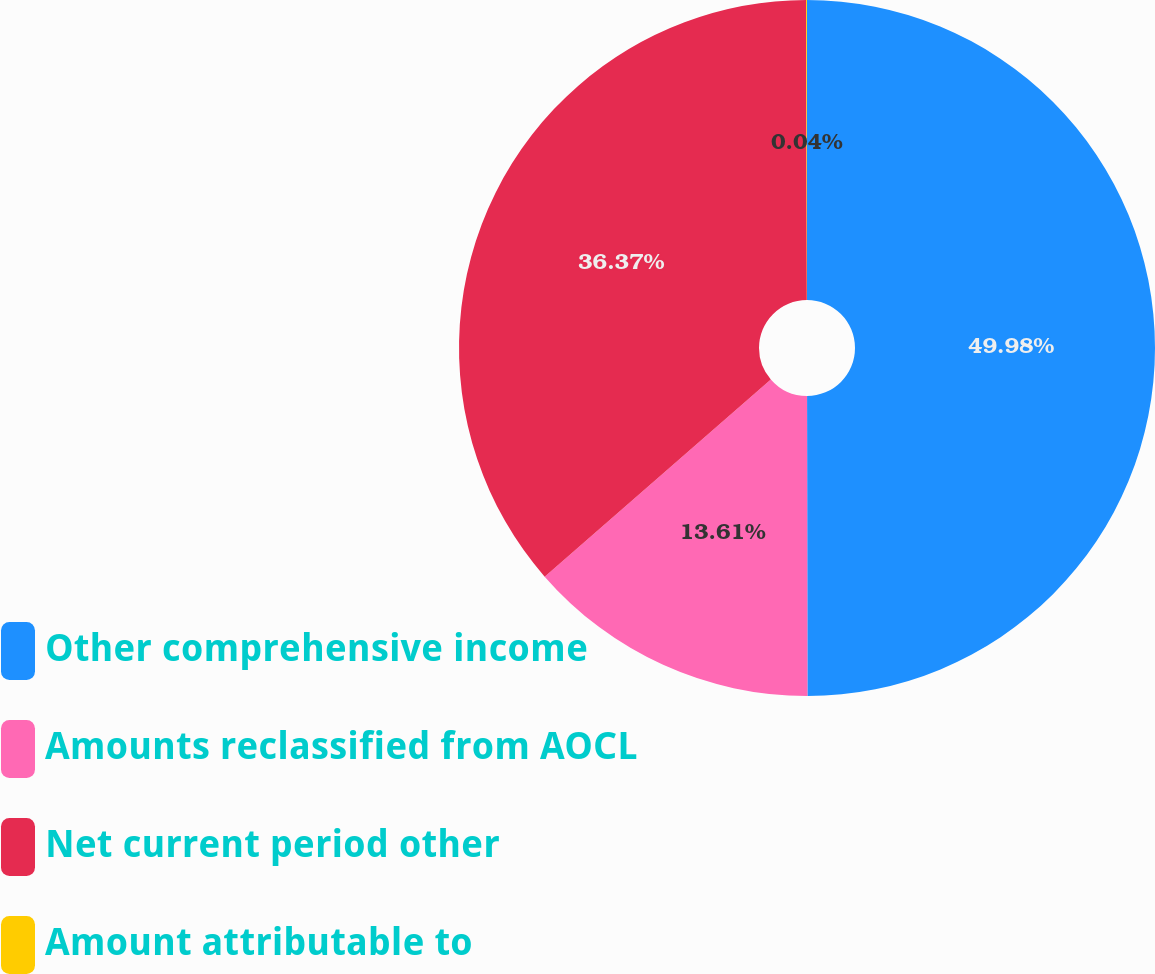Convert chart to OTSL. <chart><loc_0><loc_0><loc_500><loc_500><pie_chart><fcel>Other comprehensive income<fcel>Amounts reclassified from AOCL<fcel>Net current period other<fcel>Amount attributable to<nl><fcel>49.98%<fcel>13.61%<fcel>36.37%<fcel>0.04%<nl></chart> 